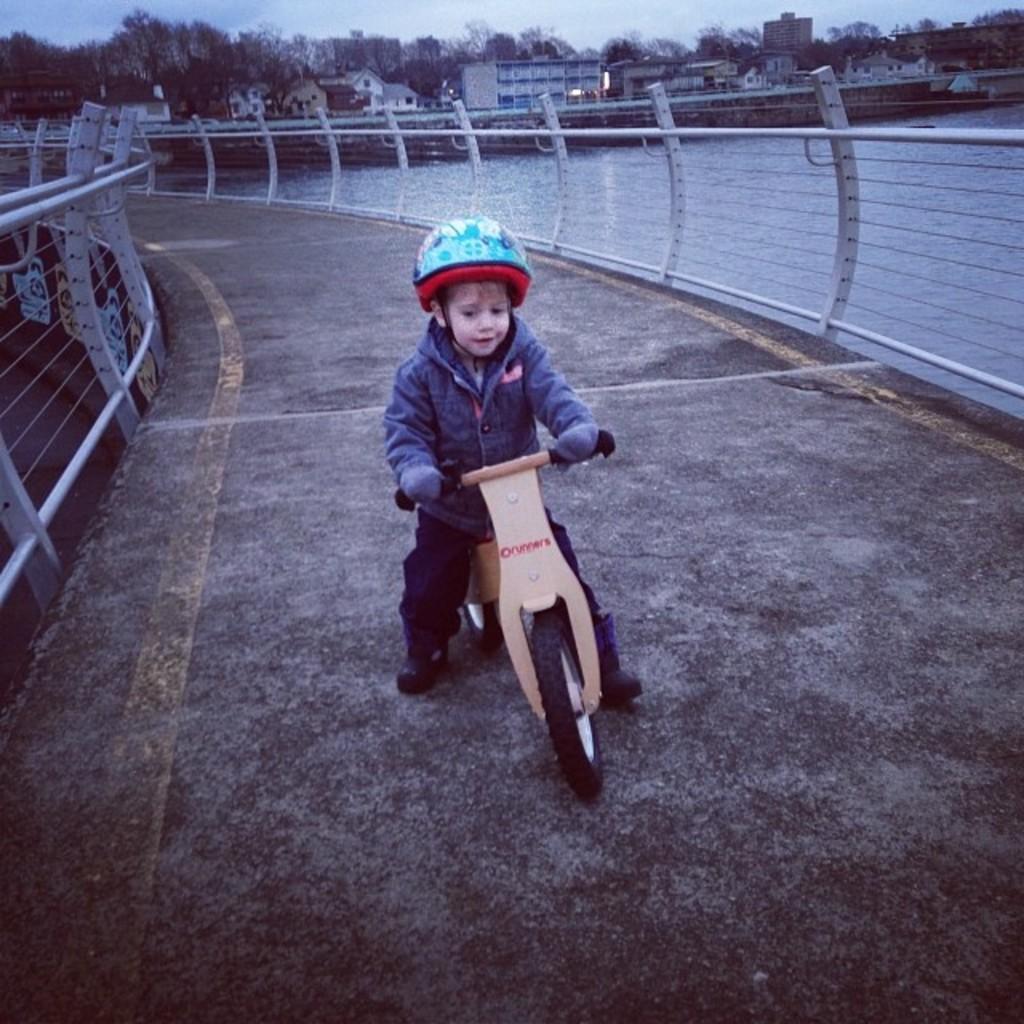Please provide a concise description of this image. This is a picture consist of a bridge near to the lake and on the background I can see a buildings ,sky and trees are visible. On the bridge a boy riding on a bi-cycle and wearing a blue color jacket and wearing a helmet o n his head. 